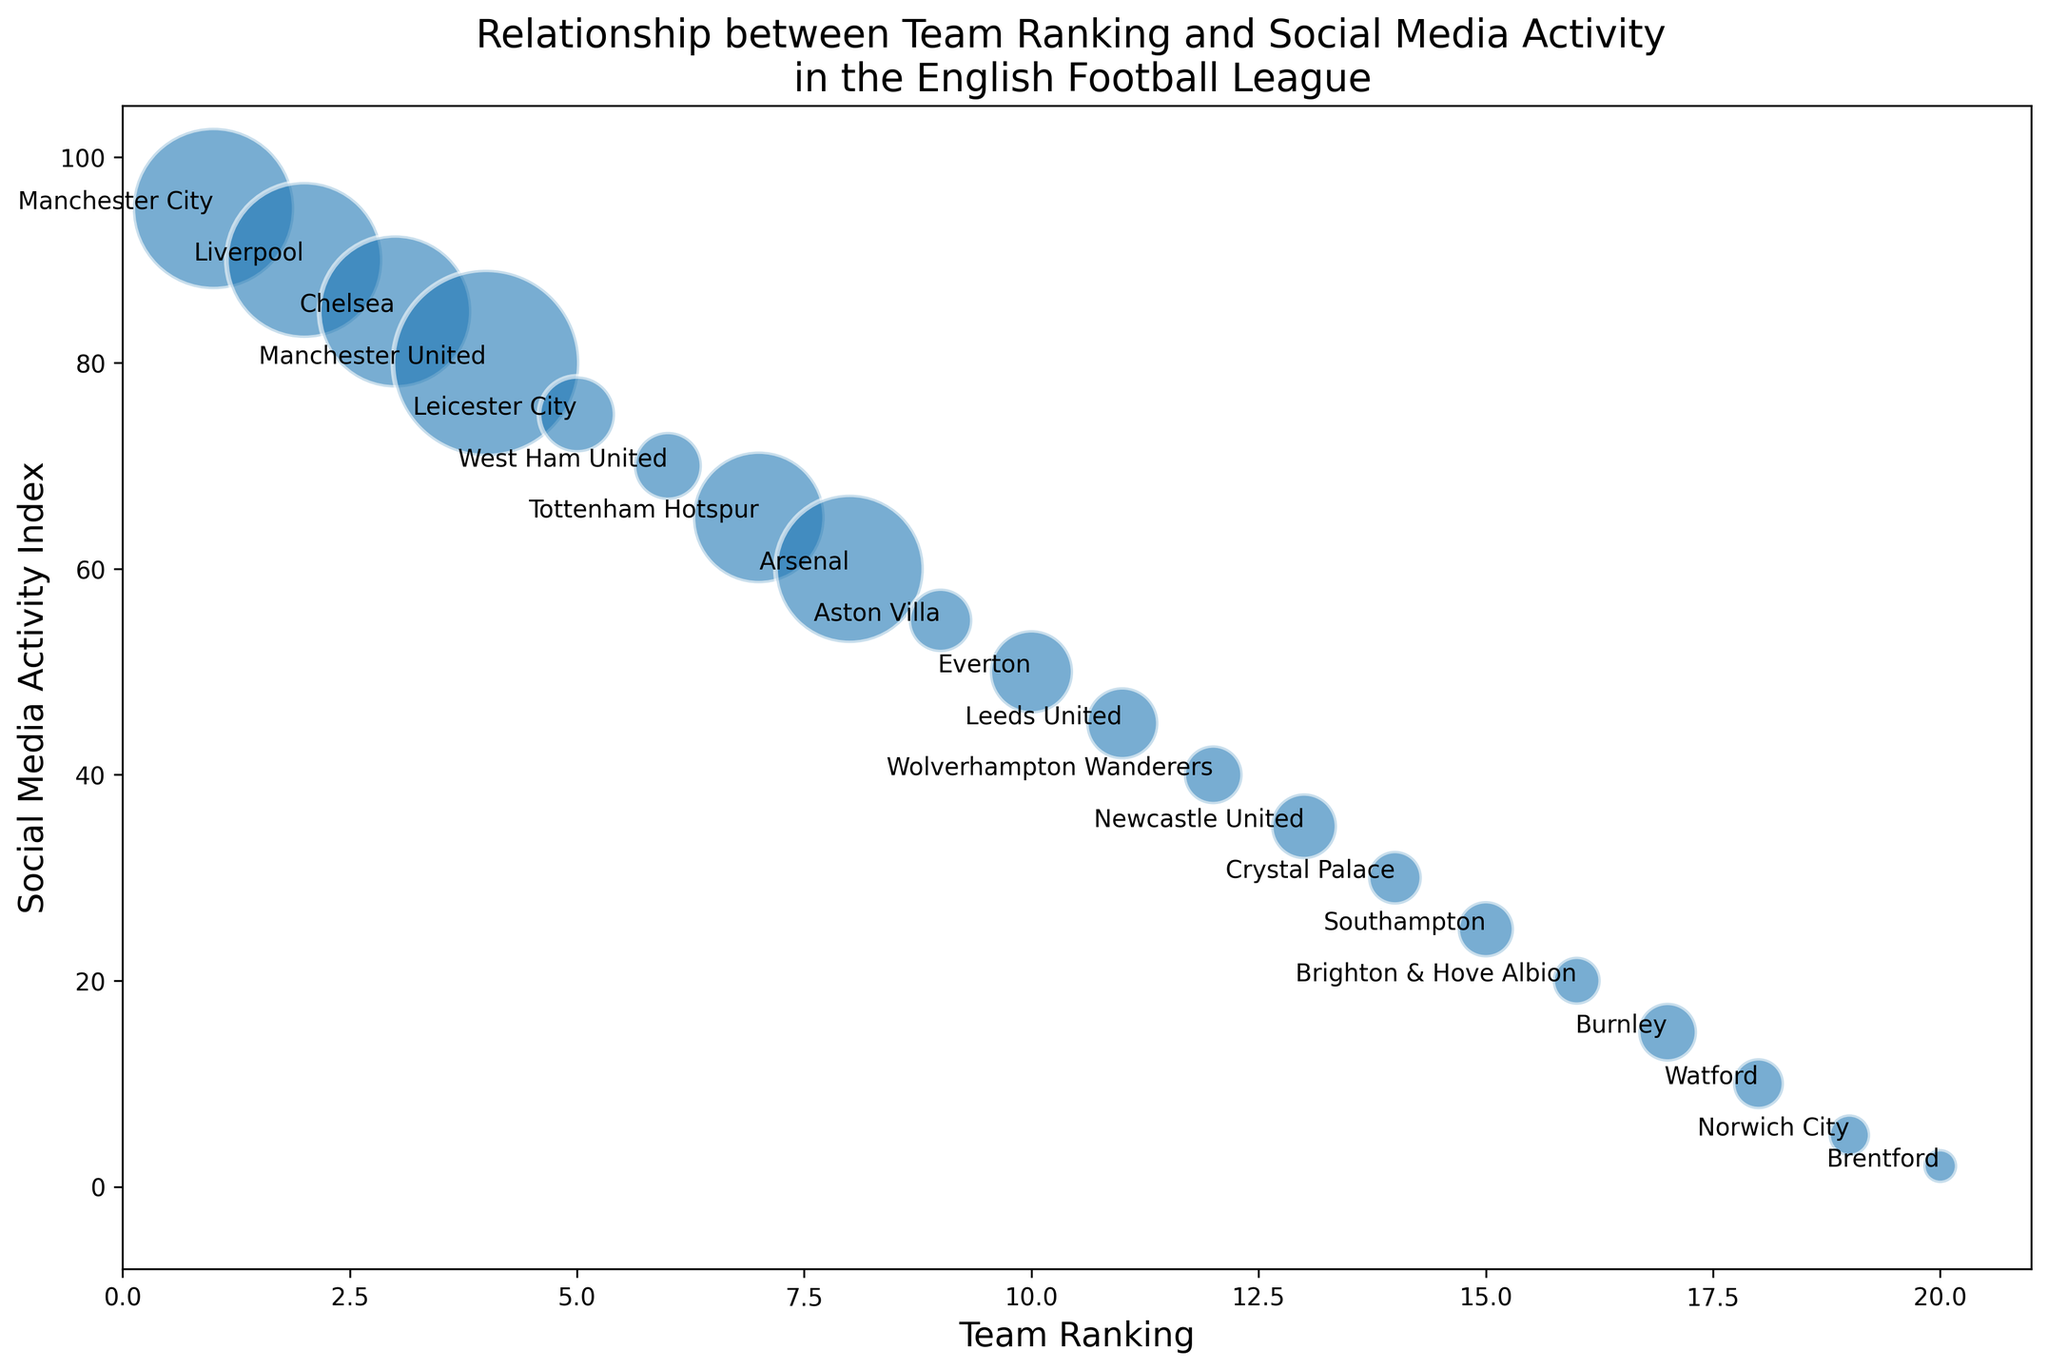Which team has the highest social media activity? By observing the vertical position of the points on the y-axis, we can see that Manchester City has the highest social media activity with a value of 95.
Answer: Manchester City Which team has the largest bubble size? Bubble size corresponds to the number of fans. Manchester United has the largest bubble size, indicating it has the most fans (6,000,000).
Answer: Manchester United What is the relationship between team ranking and social media activity for Manchester United? Manchester United has a ranking of 4 and a social media activity index of 80. The placement shows they have a high fan base despite not being at the top of the league ranking.
Answer: Ranking: 4, Social Media Activity: 80 Which team has more fans, Chelsea or Arsenal? By comparing the bubble sizes of the points representing Chelsea and Arsenal, we can see Chelsea has a larger bubble size than Arsenal. Chelsea has 4,000,000 fans, while Arsenal has 3,800,000 fans.
Answer: Chelsea What is the total social media activity for the teams in the top 3 rankings? Sum of the social media activities of Manchester City (95), Liverpool (90), and Chelsea (85). Adding them up gives 95 + 90 + 85 = 270.
Answer: 270 Which team ranked 5th and what is its corresponding social media activity? Leicester City is ranked 5th. Observing its position on the y-axis, the social media activity index is 75.
Answer: Leicester City, Social Media Activity: 75 Is there a clear relationship between team ranking and the number of fans? Teams with higher rankings do not always have more fans. For example, Manchester United has the most fans but is ranked 4th. This indicates that fanbase size and team performance are not directly proportional.
Answer: No How does West Ham United's social media activity compare to that of Everton? West Ham United has a social media activity index of 70, while Everton has a social media activity index of 50. West Ham United has higher social media activity.
Answer: West Ham United Which team has the lowest social media activity and what is its ranking? Brentford has the lowest social media activity with an index of 2. It is ranked 20th.
Answer: Brentford 